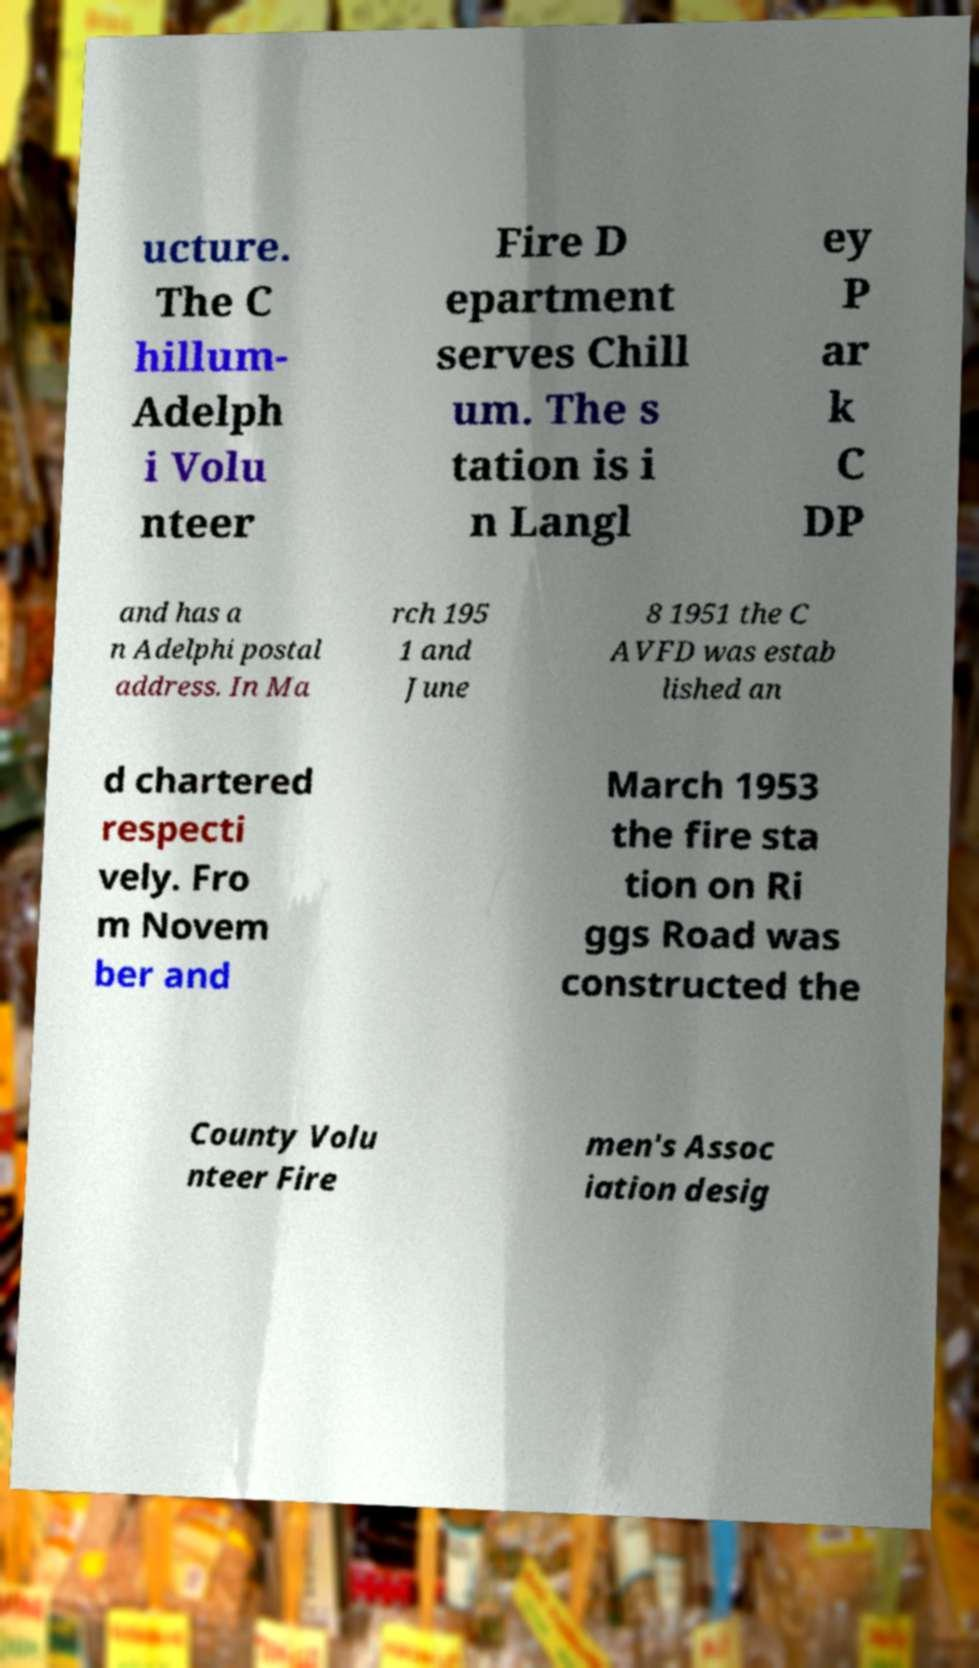What messages or text are displayed in this image? I need them in a readable, typed format. ucture. The C hillum- Adelph i Volu nteer Fire D epartment serves Chill um. The s tation is i n Langl ey P ar k C DP and has a n Adelphi postal address. In Ma rch 195 1 and June 8 1951 the C AVFD was estab lished an d chartered respecti vely. Fro m Novem ber and March 1953 the fire sta tion on Ri ggs Road was constructed the County Volu nteer Fire men's Assoc iation desig 